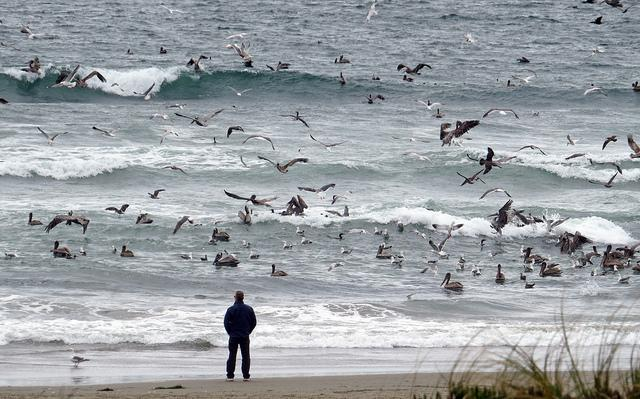What is the most diverse seashore bird? Please explain your reasoning. sandpiper. These birds come in many shapes and sizes. 